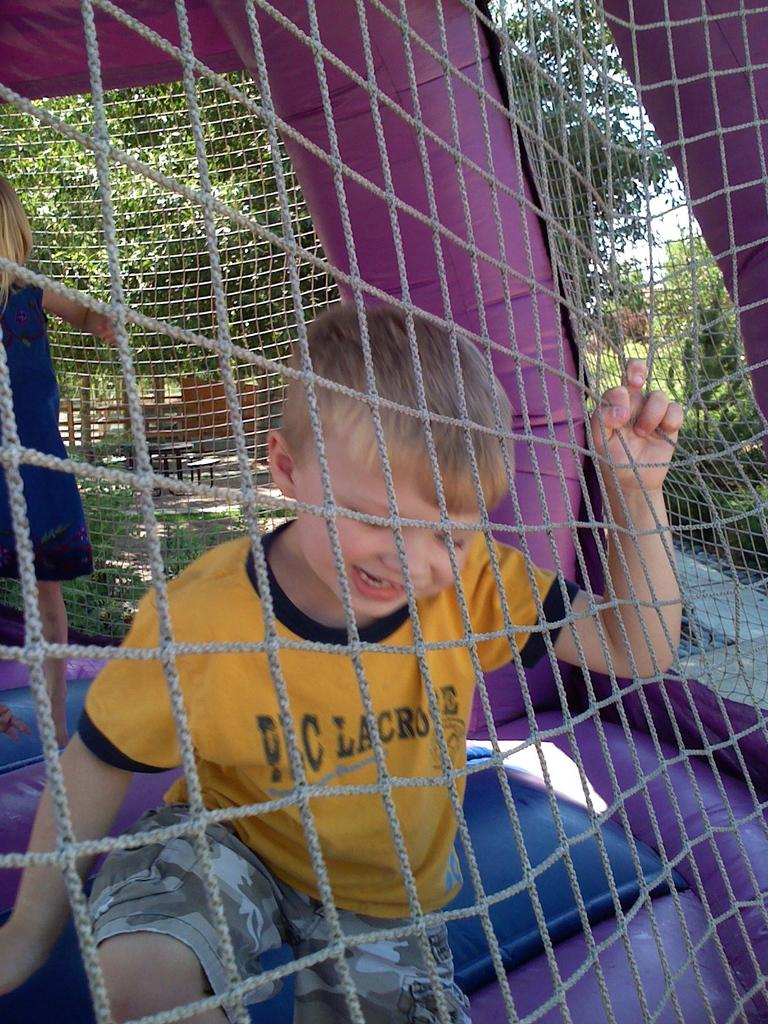Who is present in the image? There are children in the image. What object can be seen in the image? There is a net in the image. What type of oven is used by the children in the image? There is no oven present in the image; it features children and a net. 